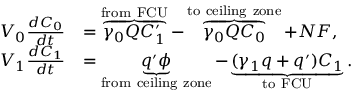<formula> <loc_0><loc_0><loc_500><loc_500>\begin{array} { r l } { V _ { 0 } \frac { d C _ { 0 } } { d t } } & { = \overbrace { \gamma _ { 0 } Q C _ { 1 } ^ { \prime } } ^ { f r o m \ F C U } - \overbrace { \gamma _ { 0 } Q C _ { 0 } } ^ { t o \ c e i l i n g \ z o n e } + N F , } \\ { V _ { 1 } \frac { d C _ { 1 } } { d t } } & { = \underbrace { q ^ { \prime } \phi } _ { f r o m \ c e i l i n g \ z o n e } - \underbrace { ( \gamma _ { 1 } q + q ^ { \prime } ) C _ { 1 } } _ { t o \ F C U } . } \end{array}</formula> 